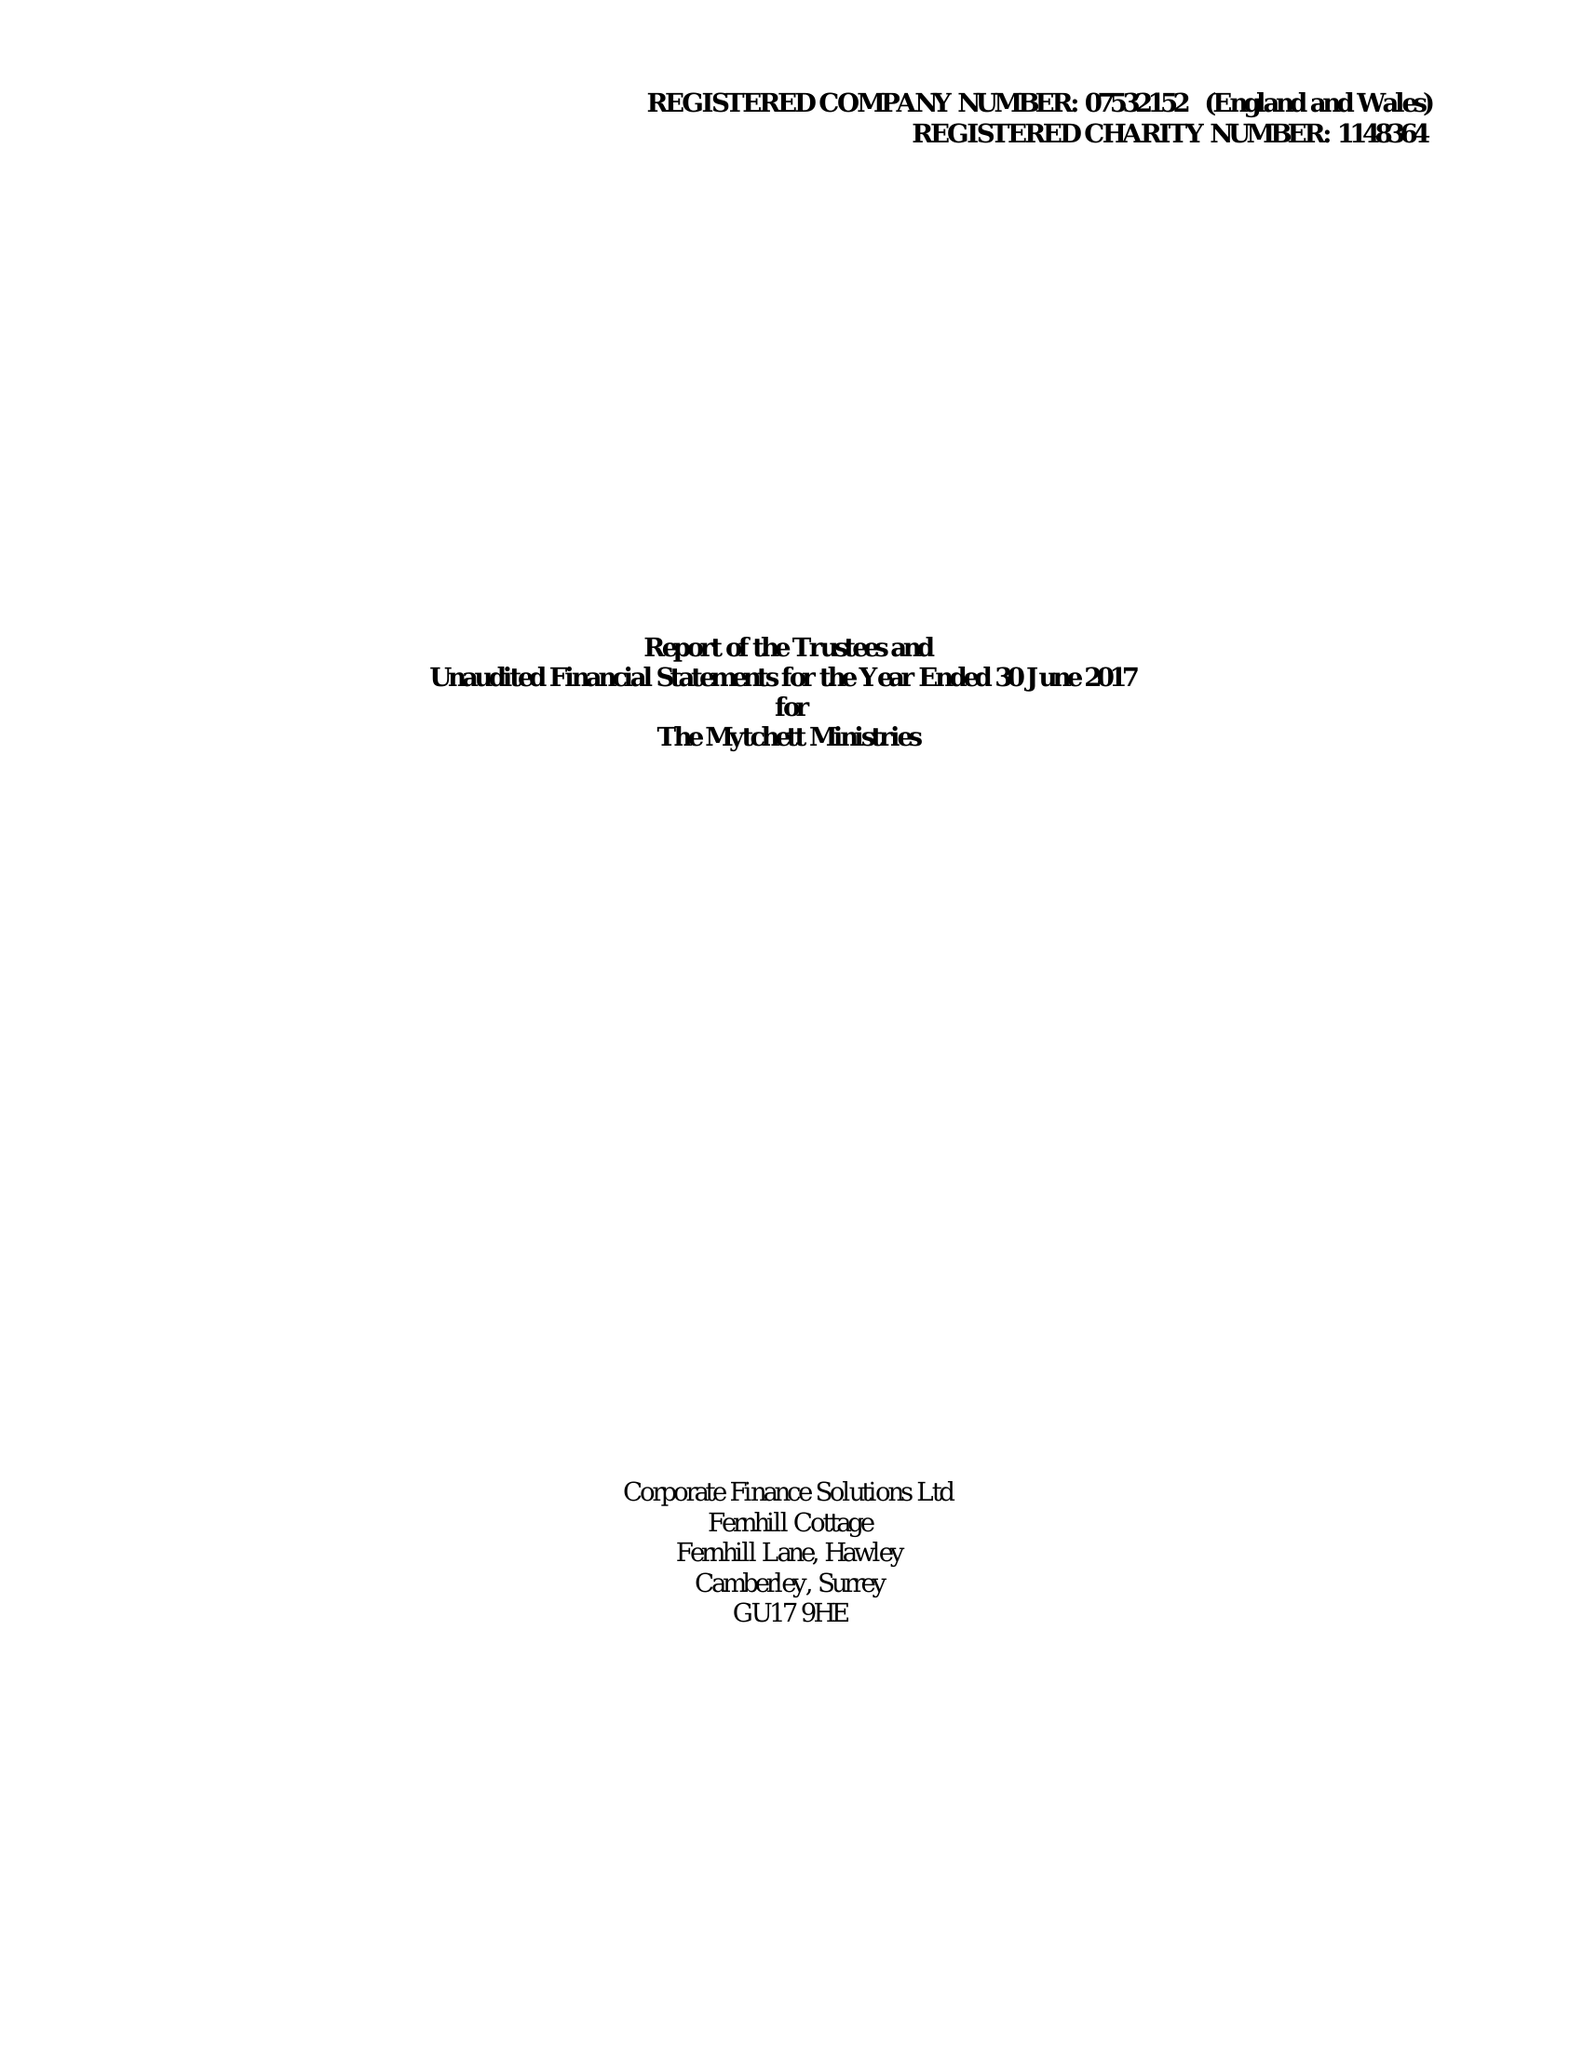What is the value for the report_date?
Answer the question using a single word or phrase. 2017-06-30 